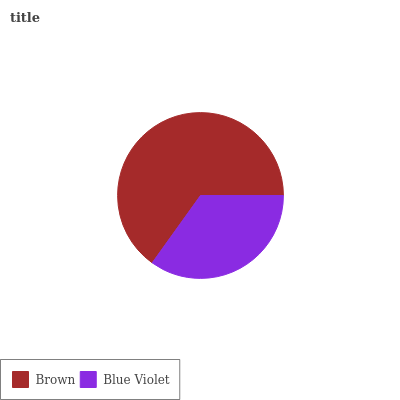Is Blue Violet the minimum?
Answer yes or no. Yes. Is Brown the maximum?
Answer yes or no. Yes. Is Blue Violet the maximum?
Answer yes or no. No. Is Brown greater than Blue Violet?
Answer yes or no. Yes. Is Blue Violet less than Brown?
Answer yes or no. Yes. Is Blue Violet greater than Brown?
Answer yes or no. No. Is Brown less than Blue Violet?
Answer yes or no. No. Is Brown the high median?
Answer yes or no. Yes. Is Blue Violet the low median?
Answer yes or no. Yes. Is Blue Violet the high median?
Answer yes or no. No. Is Brown the low median?
Answer yes or no. No. 